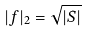Convert formula to latex. <formula><loc_0><loc_0><loc_500><loc_500>| f | _ { 2 } = \sqrt { | S | }</formula> 